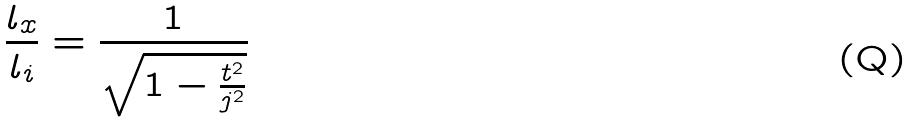<formula> <loc_0><loc_0><loc_500><loc_500>\frac { l _ { x } } { l _ { i } } = \frac { 1 } { \sqrt { 1 - \frac { t ^ { 2 } } { j ^ { 2 } } } }</formula> 